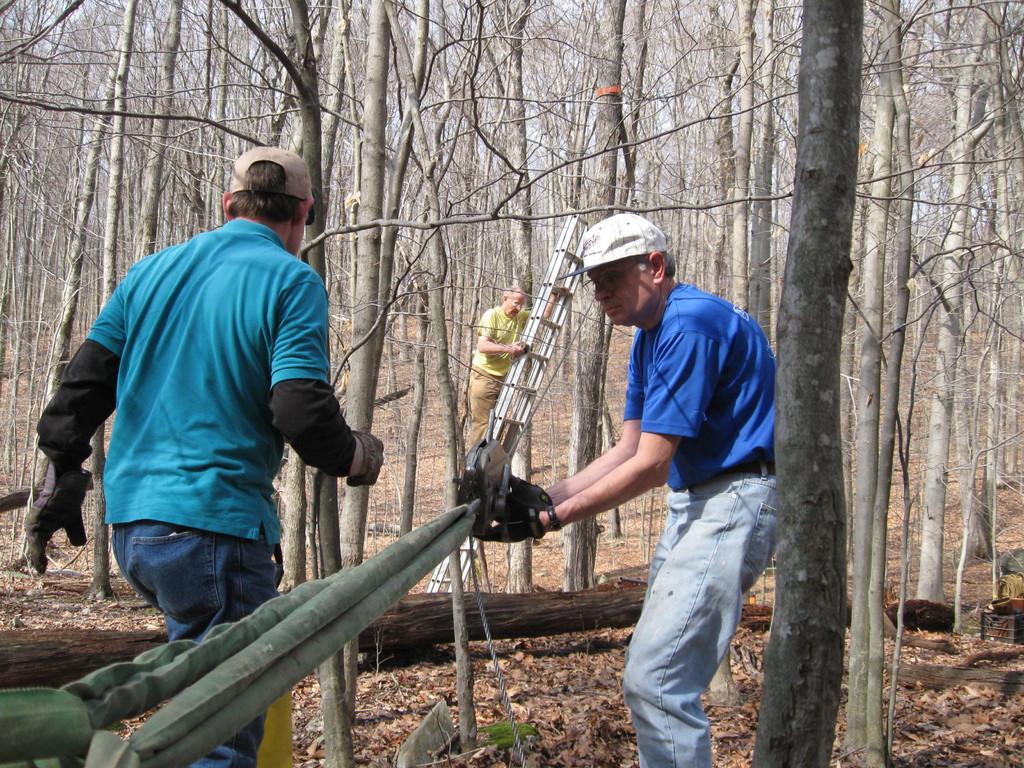In one or two sentences, can you explain what this image depicts? There are people and he is holding an object. We can see rope, ladder and green objects. We can see trees. 